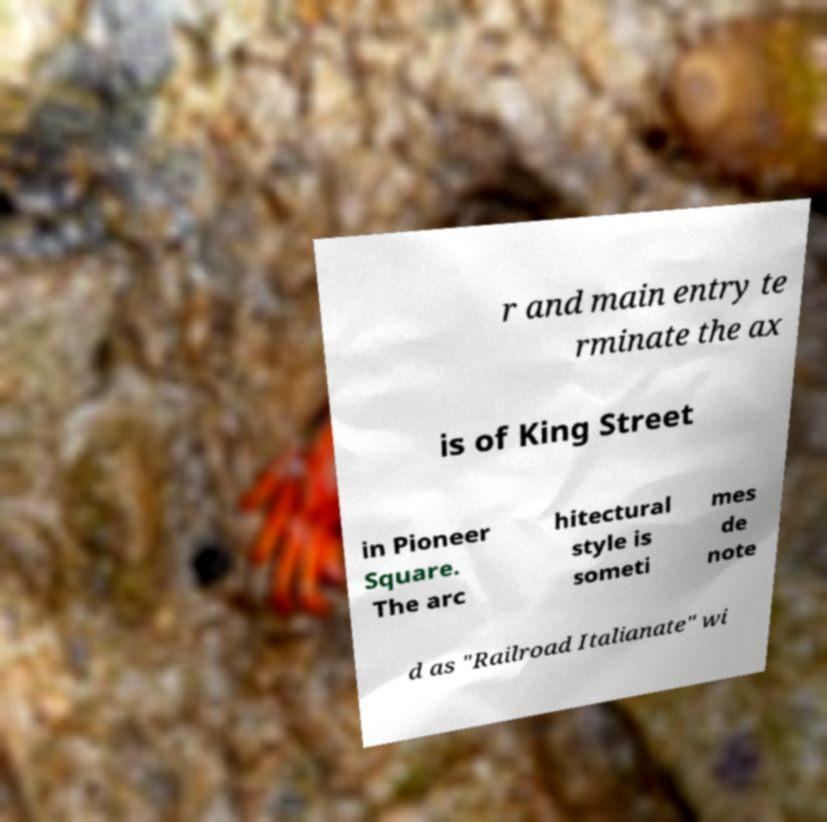For documentation purposes, I need the text within this image transcribed. Could you provide that? r and main entry te rminate the ax is of King Street in Pioneer Square. The arc hitectural style is someti mes de note d as "Railroad Italianate" wi 